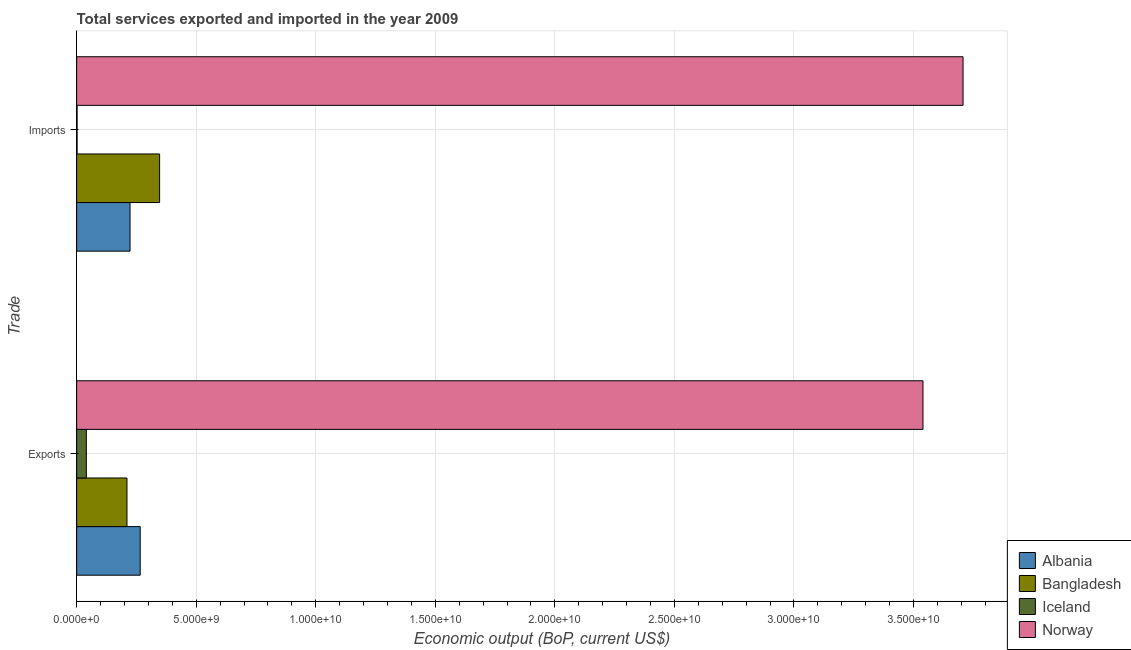Are the number of bars per tick equal to the number of legend labels?
Provide a short and direct response. Yes. How many bars are there on the 2nd tick from the top?
Make the answer very short. 4. How many bars are there on the 1st tick from the bottom?
Ensure brevity in your answer.  4. What is the label of the 1st group of bars from the top?
Offer a terse response. Imports. What is the amount of service imports in Norway?
Your response must be concise. 3.71e+1. Across all countries, what is the maximum amount of service imports?
Offer a terse response. 3.71e+1. Across all countries, what is the minimum amount of service imports?
Give a very brief answer. 1.81e+07. In which country was the amount of service imports maximum?
Your response must be concise. Norway. In which country was the amount of service exports minimum?
Offer a very short reply. Iceland. What is the total amount of service exports in the graph?
Give a very brief answer. 4.06e+1. What is the difference between the amount of service imports in Norway and that in Bangladesh?
Make the answer very short. 3.36e+1. What is the difference between the amount of service imports in Albania and the amount of service exports in Iceland?
Provide a succinct answer. 1.83e+09. What is the average amount of service exports per country?
Your answer should be very brief. 1.01e+1. What is the difference between the amount of service imports and amount of service exports in Albania?
Provide a succinct answer. -4.25e+08. In how many countries, is the amount of service imports greater than 25000000000 US$?
Your response must be concise. 1. What is the ratio of the amount of service exports in Albania to that in Bangladesh?
Your answer should be compact. 1.26. Is the amount of service exports in Iceland less than that in Norway?
Ensure brevity in your answer.  Yes. In how many countries, is the amount of service imports greater than the average amount of service imports taken over all countries?
Ensure brevity in your answer.  1. What does the 2nd bar from the top in Imports represents?
Offer a terse response. Iceland. What does the 3rd bar from the bottom in Exports represents?
Provide a succinct answer. Iceland. Are all the bars in the graph horizontal?
Ensure brevity in your answer.  Yes. How many countries are there in the graph?
Make the answer very short. 4. What is the difference between two consecutive major ticks on the X-axis?
Make the answer very short. 5.00e+09. Does the graph contain any zero values?
Offer a terse response. No. Where does the legend appear in the graph?
Your answer should be compact. Bottom right. How many legend labels are there?
Your answer should be very brief. 4. What is the title of the graph?
Ensure brevity in your answer.  Total services exported and imported in the year 2009. What is the label or title of the X-axis?
Your answer should be compact. Economic output (BoP, current US$). What is the label or title of the Y-axis?
Give a very brief answer. Trade. What is the Economic output (BoP, current US$) in Albania in Exports?
Your response must be concise. 2.66e+09. What is the Economic output (BoP, current US$) of Bangladesh in Exports?
Provide a succinct answer. 2.10e+09. What is the Economic output (BoP, current US$) of Iceland in Exports?
Your response must be concise. 4.06e+08. What is the Economic output (BoP, current US$) of Norway in Exports?
Offer a terse response. 3.54e+1. What is the Economic output (BoP, current US$) of Albania in Imports?
Provide a short and direct response. 2.23e+09. What is the Economic output (BoP, current US$) of Bangladesh in Imports?
Ensure brevity in your answer.  3.47e+09. What is the Economic output (BoP, current US$) of Iceland in Imports?
Ensure brevity in your answer.  1.81e+07. What is the Economic output (BoP, current US$) in Norway in Imports?
Your response must be concise. 3.71e+1. Across all Trade, what is the maximum Economic output (BoP, current US$) of Albania?
Keep it short and to the point. 2.66e+09. Across all Trade, what is the maximum Economic output (BoP, current US$) in Bangladesh?
Provide a succinct answer. 3.47e+09. Across all Trade, what is the maximum Economic output (BoP, current US$) of Iceland?
Offer a terse response. 4.06e+08. Across all Trade, what is the maximum Economic output (BoP, current US$) in Norway?
Ensure brevity in your answer.  3.71e+1. Across all Trade, what is the minimum Economic output (BoP, current US$) in Albania?
Give a very brief answer. 2.23e+09. Across all Trade, what is the minimum Economic output (BoP, current US$) in Bangladesh?
Offer a terse response. 2.10e+09. Across all Trade, what is the minimum Economic output (BoP, current US$) of Iceland?
Your answer should be compact. 1.81e+07. Across all Trade, what is the minimum Economic output (BoP, current US$) of Norway?
Keep it short and to the point. 3.54e+1. What is the total Economic output (BoP, current US$) in Albania in the graph?
Offer a very short reply. 4.89e+09. What is the total Economic output (BoP, current US$) in Bangladesh in the graph?
Give a very brief answer. 5.57e+09. What is the total Economic output (BoP, current US$) of Iceland in the graph?
Offer a terse response. 4.24e+08. What is the total Economic output (BoP, current US$) of Norway in the graph?
Provide a succinct answer. 7.25e+1. What is the difference between the Economic output (BoP, current US$) in Albania in Exports and that in Imports?
Offer a terse response. 4.25e+08. What is the difference between the Economic output (BoP, current US$) of Bangladesh in Exports and that in Imports?
Make the answer very short. -1.36e+09. What is the difference between the Economic output (BoP, current US$) of Iceland in Exports and that in Imports?
Your answer should be very brief. 3.88e+08. What is the difference between the Economic output (BoP, current US$) in Norway in Exports and that in Imports?
Offer a terse response. -1.68e+09. What is the difference between the Economic output (BoP, current US$) in Albania in Exports and the Economic output (BoP, current US$) in Bangladesh in Imports?
Your response must be concise. -8.11e+08. What is the difference between the Economic output (BoP, current US$) of Albania in Exports and the Economic output (BoP, current US$) of Iceland in Imports?
Your answer should be very brief. 2.64e+09. What is the difference between the Economic output (BoP, current US$) of Albania in Exports and the Economic output (BoP, current US$) of Norway in Imports?
Make the answer very short. -3.44e+1. What is the difference between the Economic output (BoP, current US$) of Bangladesh in Exports and the Economic output (BoP, current US$) of Iceland in Imports?
Offer a very short reply. 2.09e+09. What is the difference between the Economic output (BoP, current US$) in Bangladesh in Exports and the Economic output (BoP, current US$) in Norway in Imports?
Provide a succinct answer. -3.50e+1. What is the difference between the Economic output (BoP, current US$) in Iceland in Exports and the Economic output (BoP, current US$) in Norway in Imports?
Offer a terse response. -3.67e+1. What is the average Economic output (BoP, current US$) of Albania per Trade?
Offer a very short reply. 2.45e+09. What is the average Economic output (BoP, current US$) in Bangladesh per Trade?
Provide a short and direct response. 2.79e+09. What is the average Economic output (BoP, current US$) of Iceland per Trade?
Provide a short and direct response. 2.12e+08. What is the average Economic output (BoP, current US$) of Norway per Trade?
Provide a short and direct response. 3.62e+1. What is the difference between the Economic output (BoP, current US$) of Albania and Economic output (BoP, current US$) of Bangladesh in Exports?
Keep it short and to the point. 5.54e+08. What is the difference between the Economic output (BoP, current US$) of Albania and Economic output (BoP, current US$) of Iceland in Exports?
Ensure brevity in your answer.  2.25e+09. What is the difference between the Economic output (BoP, current US$) of Albania and Economic output (BoP, current US$) of Norway in Exports?
Your answer should be very brief. -3.27e+1. What is the difference between the Economic output (BoP, current US$) of Bangladesh and Economic output (BoP, current US$) of Iceland in Exports?
Your answer should be compact. 1.70e+09. What is the difference between the Economic output (BoP, current US$) of Bangladesh and Economic output (BoP, current US$) of Norway in Exports?
Your response must be concise. -3.33e+1. What is the difference between the Economic output (BoP, current US$) in Iceland and Economic output (BoP, current US$) in Norway in Exports?
Offer a terse response. -3.50e+1. What is the difference between the Economic output (BoP, current US$) in Albania and Economic output (BoP, current US$) in Bangladesh in Imports?
Offer a very short reply. -1.24e+09. What is the difference between the Economic output (BoP, current US$) in Albania and Economic output (BoP, current US$) in Iceland in Imports?
Ensure brevity in your answer.  2.21e+09. What is the difference between the Economic output (BoP, current US$) of Albania and Economic output (BoP, current US$) of Norway in Imports?
Provide a short and direct response. -3.48e+1. What is the difference between the Economic output (BoP, current US$) in Bangladesh and Economic output (BoP, current US$) in Iceland in Imports?
Provide a short and direct response. 3.45e+09. What is the difference between the Economic output (BoP, current US$) in Bangladesh and Economic output (BoP, current US$) in Norway in Imports?
Offer a very short reply. -3.36e+1. What is the difference between the Economic output (BoP, current US$) of Iceland and Economic output (BoP, current US$) of Norway in Imports?
Your response must be concise. -3.71e+1. What is the ratio of the Economic output (BoP, current US$) in Albania in Exports to that in Imports?
Provide a short and direct response. 1.19. What is the ratio of the Economic output (BoP, current US$) of Bangladesh in Exports to that in Imports?
Provide a succinct answer. 0.61. What is the ratio of the Economic output (BoP, current US$) in Iceland in Exports to that in Imports?
Your answer should be compact. 22.42. What is the ratio of the Economic output (BoP, current US$) of Norway in Exports to that in Imports?
Keep it short and to the point. 0.95. What is the difference between the highest and the second highest Economic output (BoP, current US$) of Albania?
Your answer should be compact. 4.25e+08. What is the difference between the highest and the second highest Economic output (BoP, current US$) of Bangladesh?
Make the answer very short. 1.36e+09. What is the difference between the highest and the second highest Economic output (BoP, current US$) of Iceland?
Offer a terse response. 3.88e+08. What is the difference between the highest and the second highest Economic output (BoP, current US$) in Norway?
Ensure brevity in your answer.  1.68e+09. What is the difference between the highest and the lowest Economic output (BoP, current US$) in Albania?
Offer a terse response. 4.25e+08. What is the difference between the highest and the lowest Economic output (BoP, current US$) of Bangladesh?
Your response must be concise. 1.36e+09. What is the difference between the highest and the lowest Economic output (BoP, current US$) of Iceland?
Provide a short and direct response. 3.88e+08. What is the difference between the highest and the lowest Economic output (BoP, current US$) of Norway?
Provide a succinct answer. 1.68e+09. 